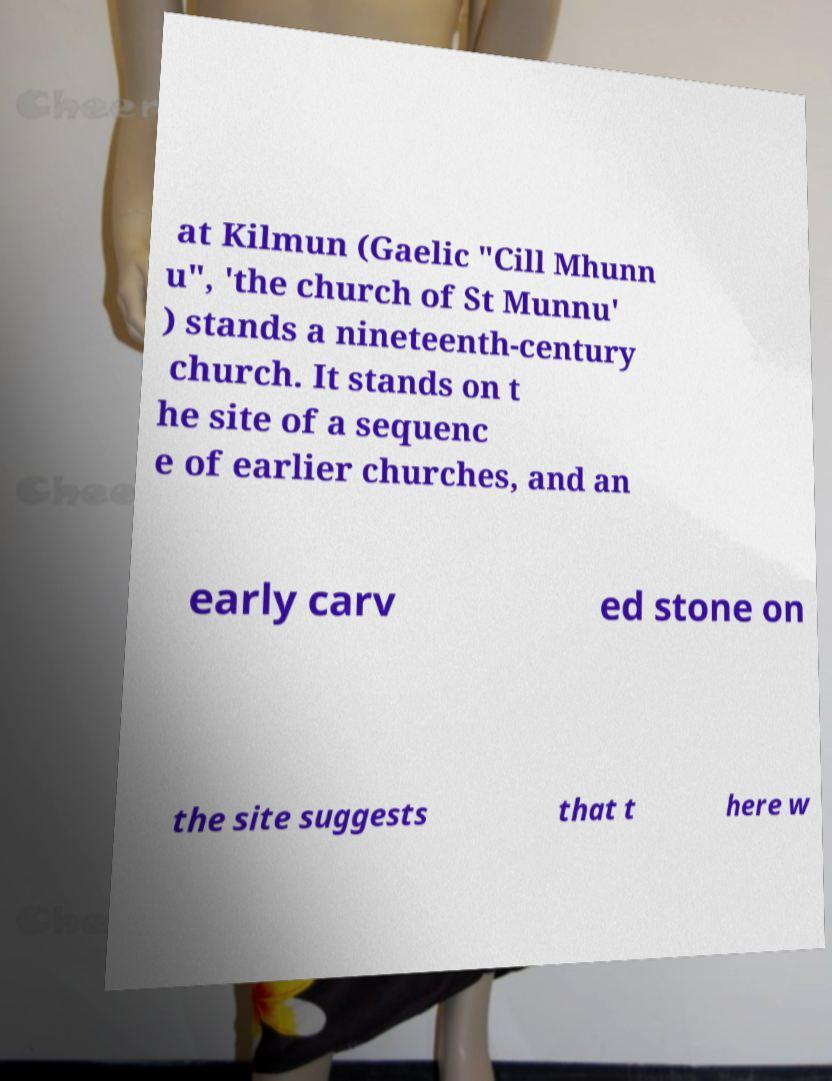I need the written content from this picture converted into text. Can you do that? at Kilmun (Gaelic "Cill Mhunn u", 'the church of St Munnu' ) stands a nineteenth-century church. It stands on t he site of a sequenc e of earlier churches, and an early carv ed stone on the site suggests that t here w 